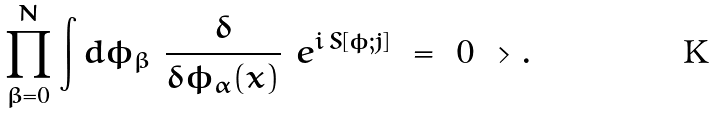<formula> <loc_0><loc_0><loc_500><loc_500>\prod _ { \beta = 0 } ^ { N } \int d \phi _ { \beta } \ \frac { \delta } { \delta \phi _ { \alpha } ( x ) } \ e ^ { i \, S [ \phi ; j ] } \ = \ 0 \ > .</formula> 